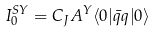<formula> <loc_0><loc_0><loc_500><loc_500>I _ { 0 } ^ { S Y } = C _ { J } A ^ { Y } \langle 0 | \bar { q } q | 0 \rangle</formula> 